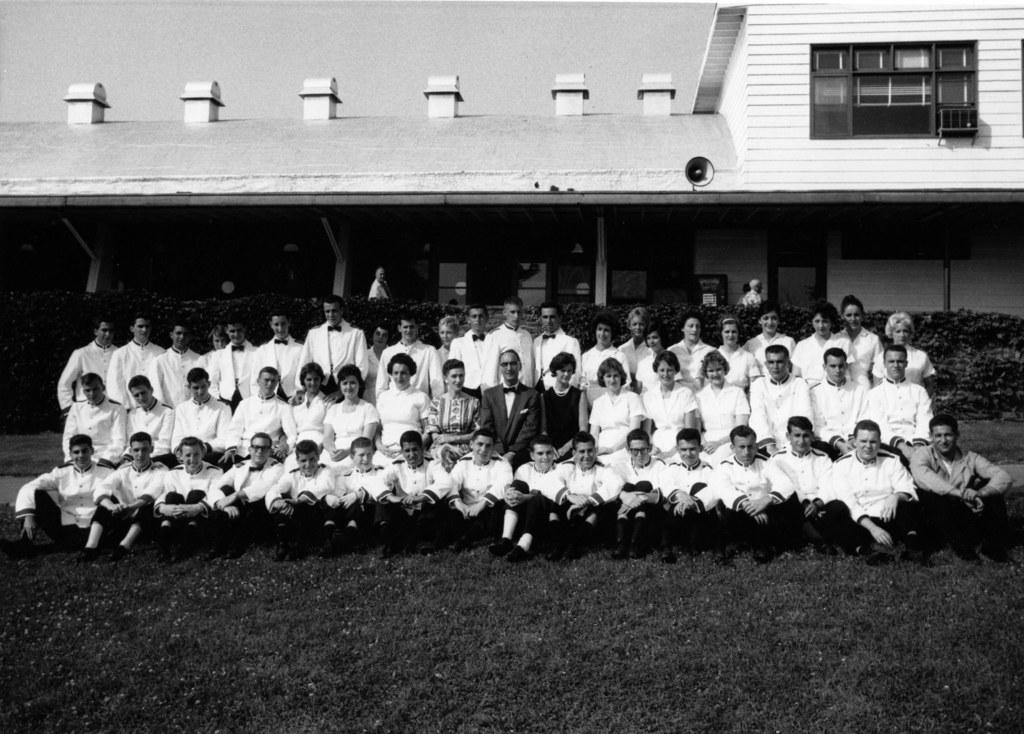How many people are in the image? There is a group of people in the image, but the exact number is not specified. What are the people in the image doing? Some people are sitting, while others are standing. What can be seen in the background of the image? There is a building and plants in the background of the image. What architectural features are present on the building? The building has windows and pillars. What type of butter is being used to care for the plants in the image? There is no butter present in the image, nor is there any indication that the plants are being cared for. 